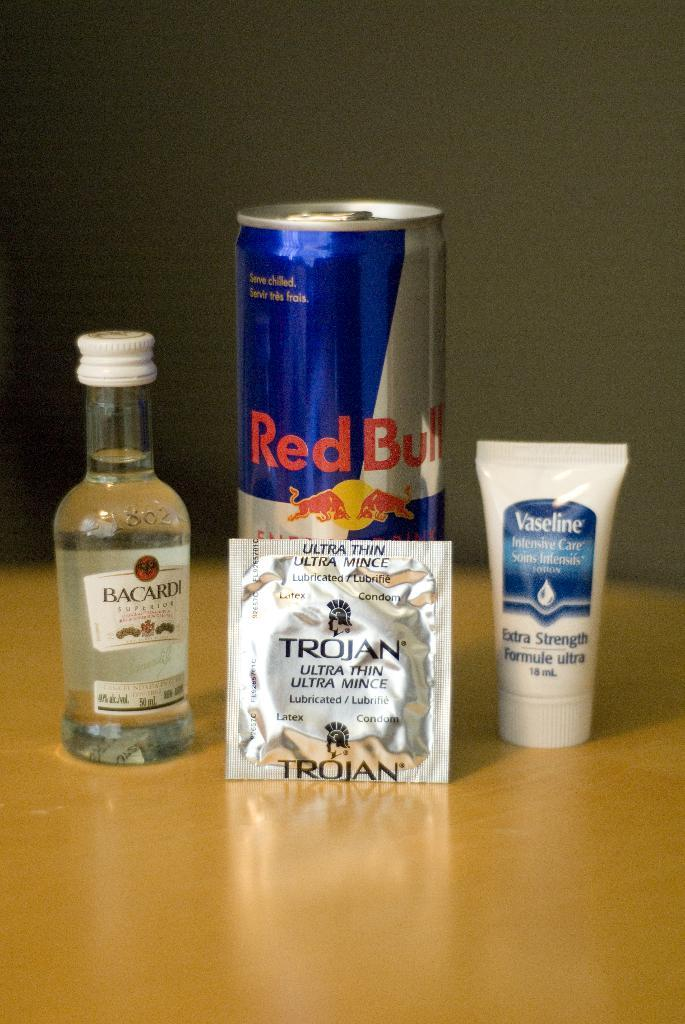<image>
Share a concise interpretation of the image provided. Trojan reads the condom package sitting in front of this Red Bull can. 